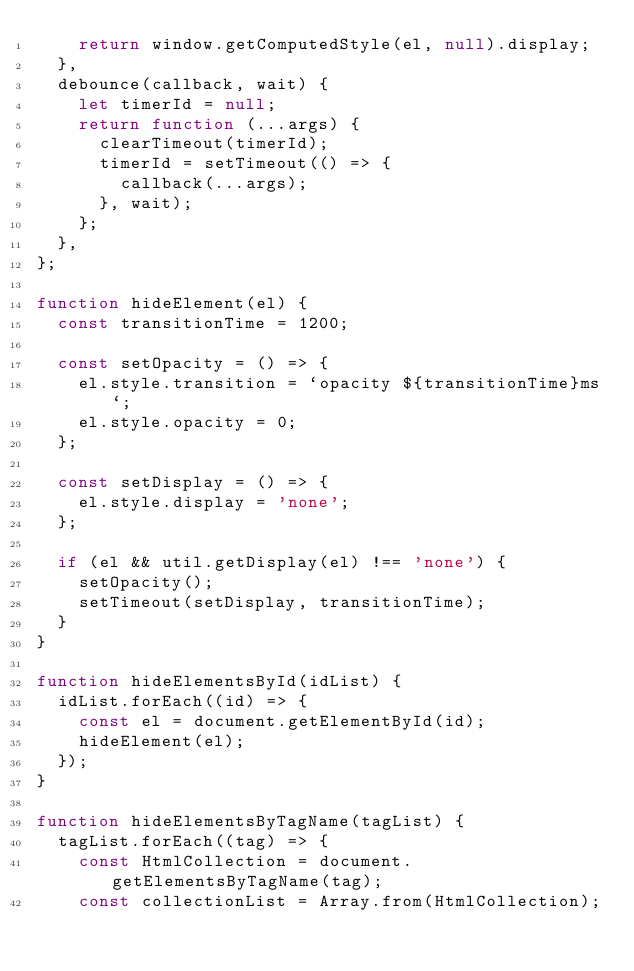<code> <loc_0><loc_0><loc_500><loc_500><_JavaScript_>    return window.getComputedStyle(el, null).display;
  },
  debounce(callback, wait) {
    let timerId = null;
    return function (...args) {
      clearTimeout(timerId);
      timerId = setTimeout(() => {
        callback(...args);
      }, wait);
    };
  },
};

function hideElement(el) {
  const transitionTime = 1200;

  const setOpacity = () => {
    el.style.transition = `opacity ${transitionTime}ms`;
    el.style.opacity = 0;
  };

  const setDisplay = () => {
    el.style.display = 'none';
  };

  if (el && util.getDisplay(el) !== 'none') {
    setOpacity();
    setTimeout(setDisplay, transitionTime);
  }
}

function hideElementsById(idList) {
  idList.forEach((id) => {
    const el = document.getElementById(id);
    hideElement(el);
  });
}

function hideElementsByTagName(tagList) {
  tagList.forEach((tag) => {
    const HtmlCollection = document.getElementsByTagName(tag);
    const collectionList = Array.from(HtmlCollection);
</code> 